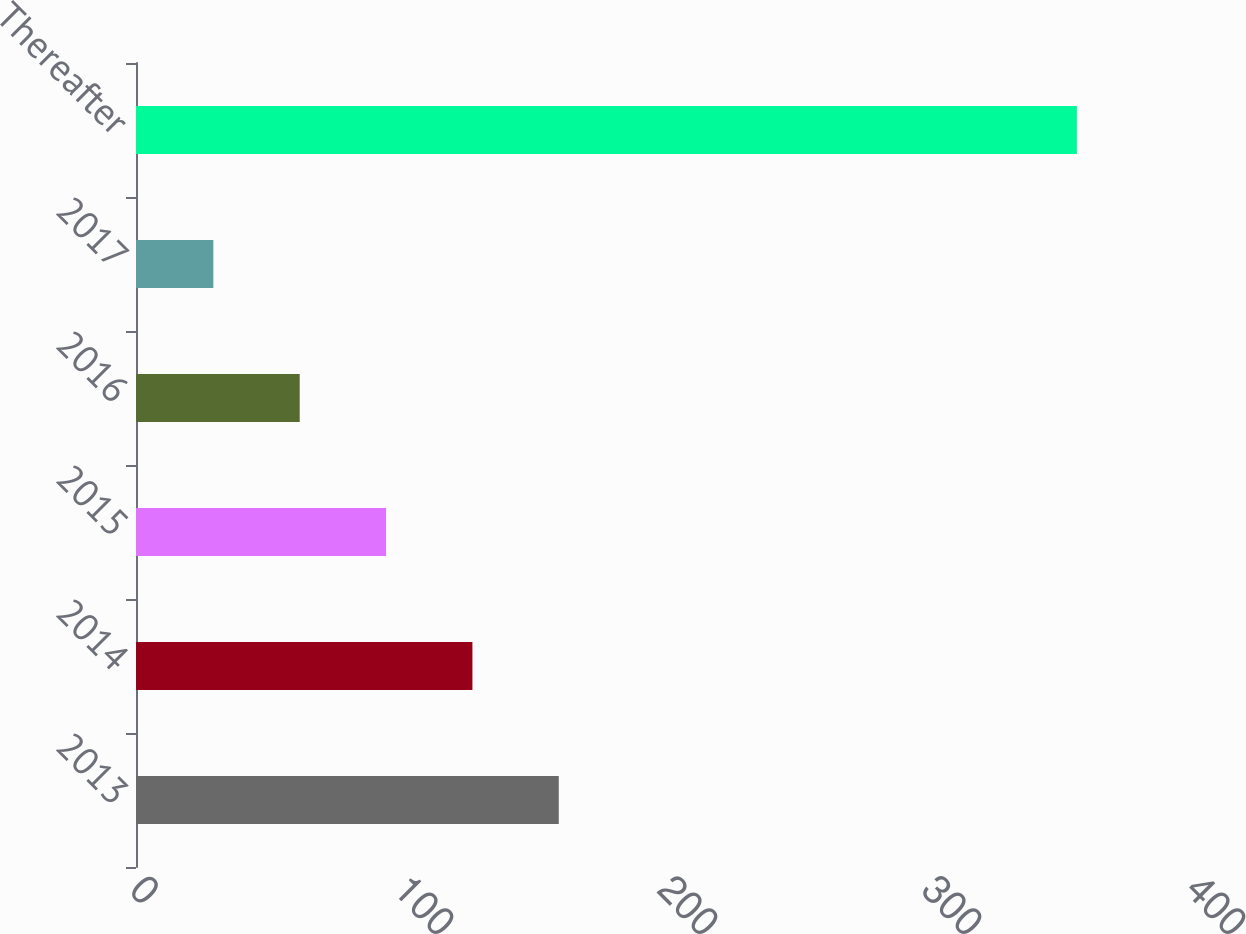<chart> <loc_0><loc_0><loc_500><loc_500><bar_chart><fcel>2013<fcel>2014<fcel>2015<fcel>2016<fcel>2017<fcel>Thereafter<nl><fcel>160.14<fcel>127.43<fcel>94.72<fcel>62.01<fcel>29.3<fcel>356.4<nl></chart> 